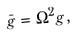Convert formula to latex. <formula><loc_0><loc_0><loc_500><loc_500>\bar { g } = \Omega ^ { 2 } g ,</formula> 